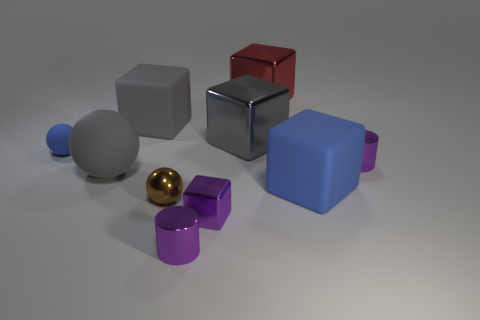Is the color of the shiny ball the same as the small rubber sphere?
Ensure brevity in your answer.  No. There is a blue object that is to the right of the blue thing that is left of the purple cylinder that is to the left of the small shiny cube; what size is it?
Your response must be concise. Large. What size is the rubber ball that is on the right side of the tiny rubber object?
Keep it short and to the point. Large. What number of things are either large gray balls or big metal blocks to the left of the big red block?
Ensure brevity in your answer.  2. How many other objects are the same size as the gray ball?
Your answer should be very brief. 4. There is a large blue object that is the same shape as the large red metallic thing; what material is it?
Make the answer very short. Rubber. Is the number of gray objects that are on the left side of the big gray sphere greater than the number of small purple cubes?
Offer a very short reply. No. Is there any other thing that has the same color as the small metal block?
Make the answer very short. Yes. What is the shape of the big gray object that is the same material as the tiny block?
Make the answer very short. Cube. Do the gray block on the right side of the tiny brown sphere and the small block have the same material?
Keep it short and to the point. Yes. 